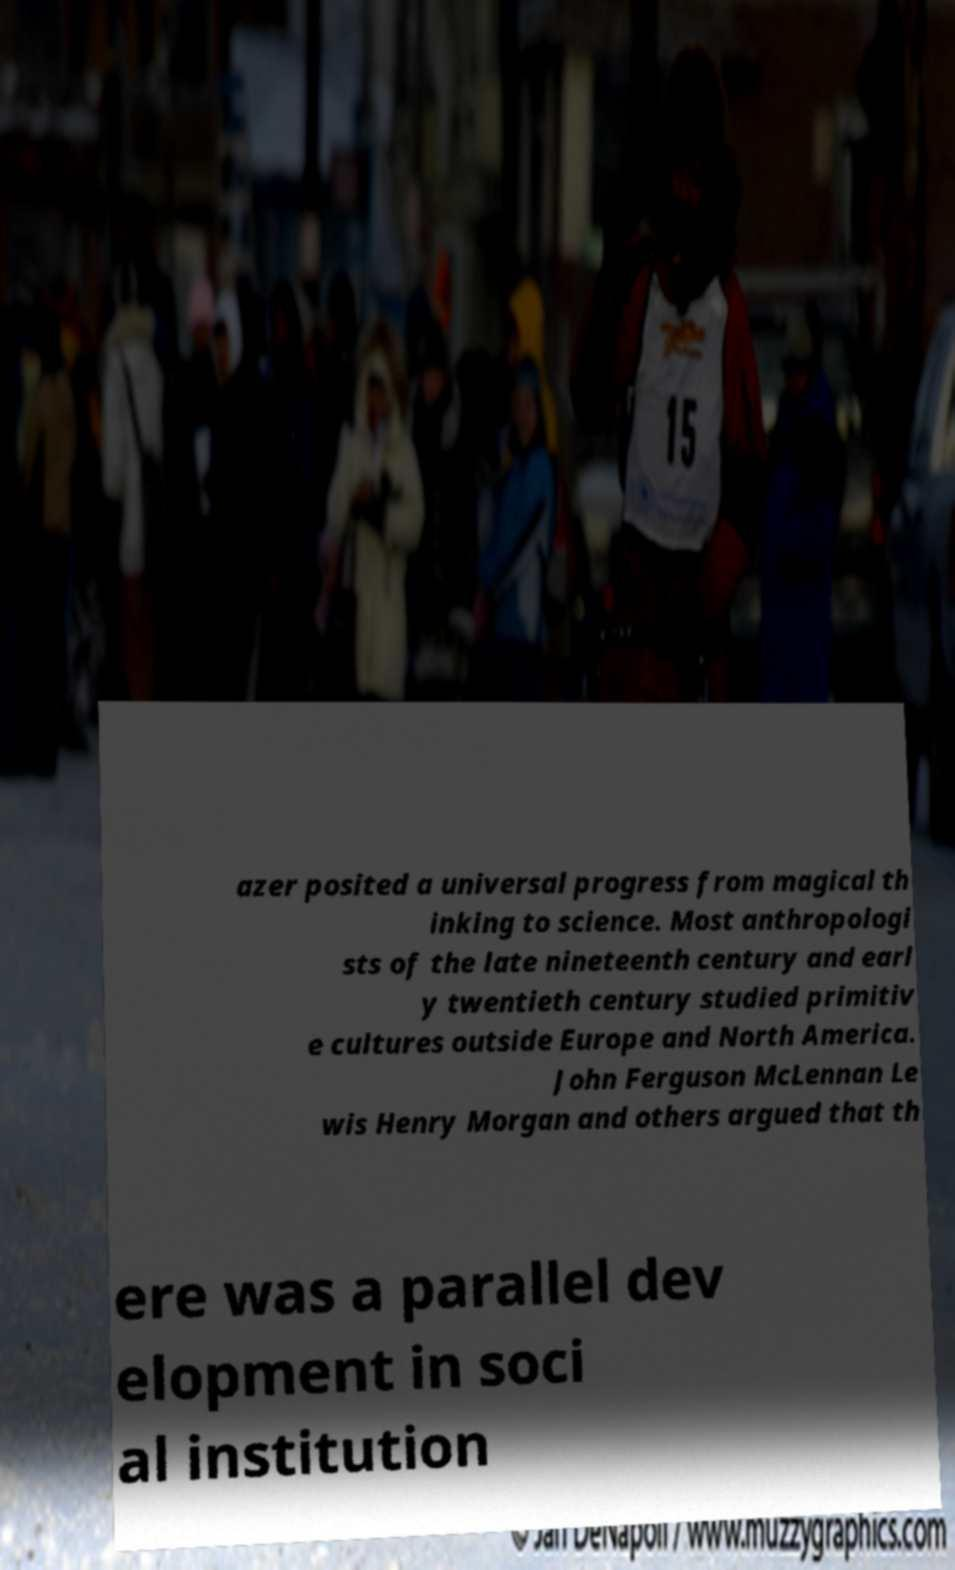I need the written content from this picture converted into text. Can you do that? azer posited a universal progress from magical th inking to science. Most anthropologi sts of the late nineteenth century and earl y twentieth century studied primitiv e cultures outside Europe and North America. John Ferguson McLennan Le wis Henry Morgan and others argued that th ere was a parallel dev elopment in soci al institution 